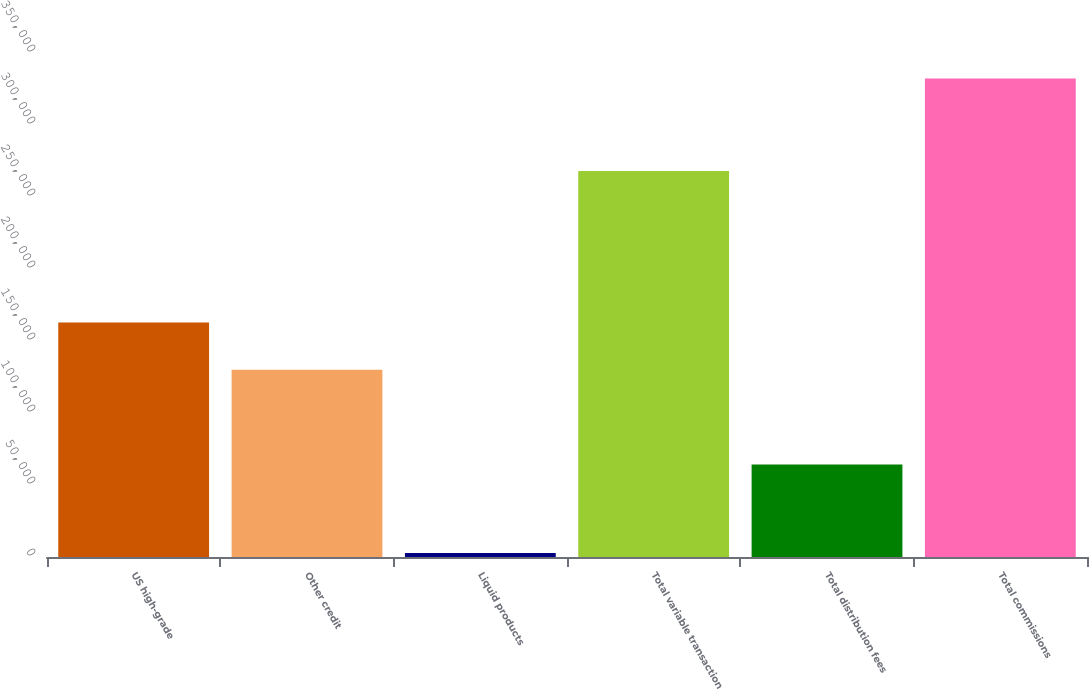Convert chart. <chart><loc_0><loc_0><loc_500><loc_500><bar_chart><fcel>US high-grade<fcel>Other credit<fcel>Liquid products<fcel>Total variable transaction<fcel>Total distribution fees<fcel>Total commissions<nl><fcel>162927<fcel>129976<fcel>2795<fcel>268066<fcel>64241<fcel>332307<nl></chart> 